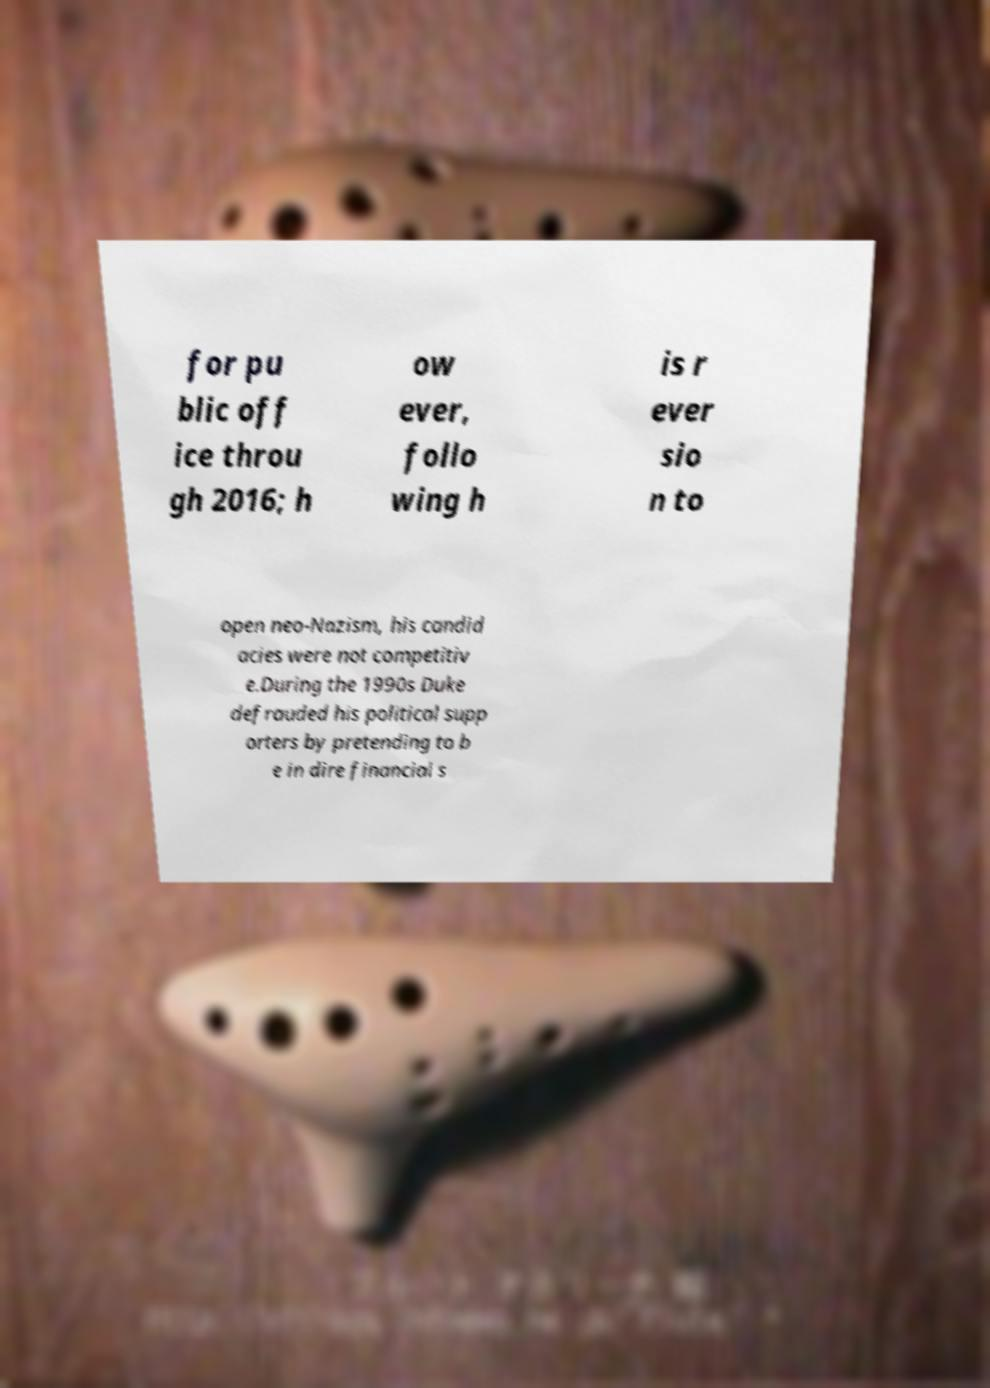There's text embedded in this image that I need extracted. Can you transcribe it verbatim? for pu blic off ice throu gh 2016; h ow ever, follo wing h is r ever sio n to open neo-Nazism, his candid acies were not competitiv e.During the 1990s Duke defrauded his political supp orters by pretending to b e in dire financial s 